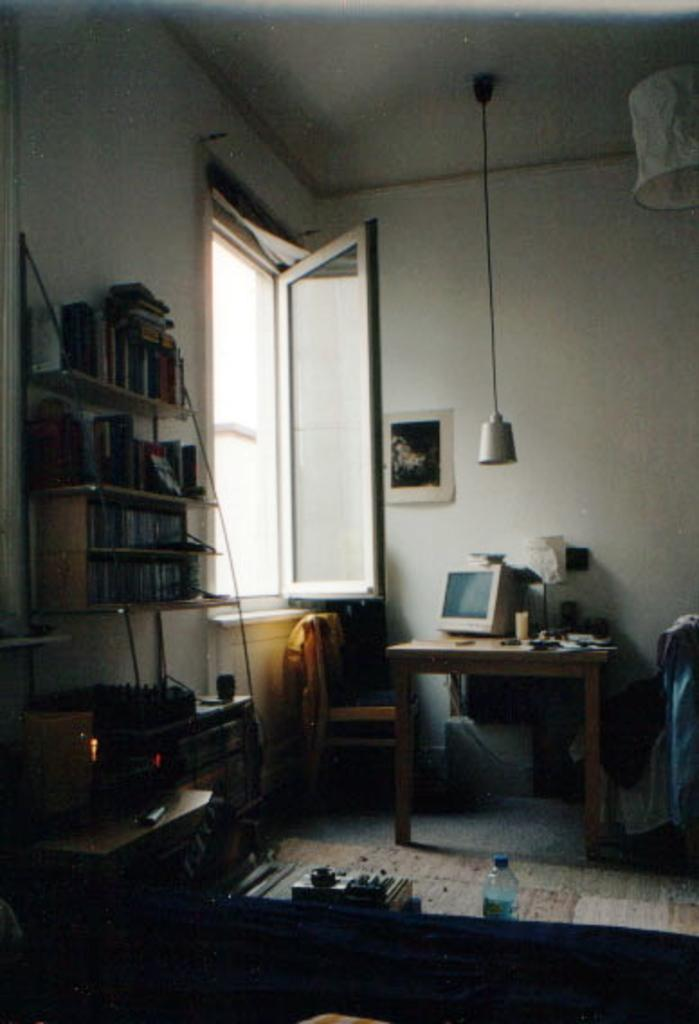What type of structure can be seen in the image? There is a wall in the image. What feature is present in the wall? There is a window in the image. What can be found on the wall? There are shelves in the image. What piece of furniture is visible in the image? There is a table in the image. What object is on the table? There is a bottle in the image. What device is present in the image? There is a switch board in the image. What electronic device is visible in the image? There is a screen in the image. Where is the throne located in the image? There is no throne present in the image. How many screws can be seen holding the screen in place? There is no information about screws or the screen's attachment method in the image. What type of bells are hanging on the wall? There are no bells present in the image. 